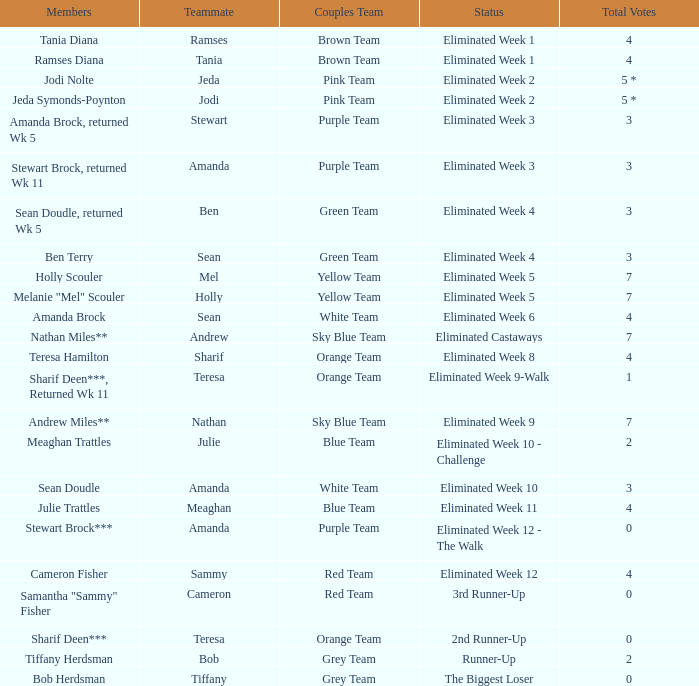Who had 0 total votes in the purple team? Eliminated Week 12 - The Walk. 